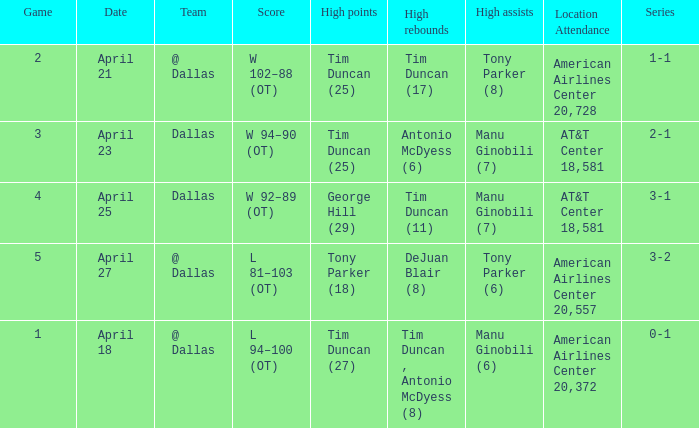Can you give me this table as a dict? {'header': ['Game', 'Date', 'Team', 'Score', 'High points', 'High rebounds', 'High assists', 'Location Attendance', 'Series'], 'rows': [['2', 'April 21', '@ Dallas', 'W 102–88 (OT)', 'Tim Duncan (25)', 'Tim Duncan (17)', 'Tony Parker (8)', 'American Airlines Center 20,728', '1-1'], ['3', 'April 23', 'Dallas', 'W 94–90 (OT)', 'Tim Duncan (25)', 'Antonio McDyess (6)', 'Manu Ginobili (7)', 'AT&T Center 18,581', '2-1'], ['4', 'April 25', 'Dallas', 'W 92–89 (OT)', 'George Hill (29)', 'Tim Duncan (11)', 'Manu Ginobili (7)', 'AT&T Center 18,581', '3-1'], ['5', 'April 27', '@ Dallas', 'L 81–103 (OT)', 'Tony Parker (18)', 'DeJuan Blair (8)', 'Tony Parker (6)', 'American Airlines Center 20,557', '3-2'], ['1', 'April 18', '@ Dallas', 'L 94–100 (OT)', 'Tim Duncan (27)', 'Tim Duncan , Antonio McDyess (8)', 'Manu Ginobili (6)', 'American Airlines Center 20,372', '0-1']]} When 1-1 is the series who is the team? @ Dallas. 